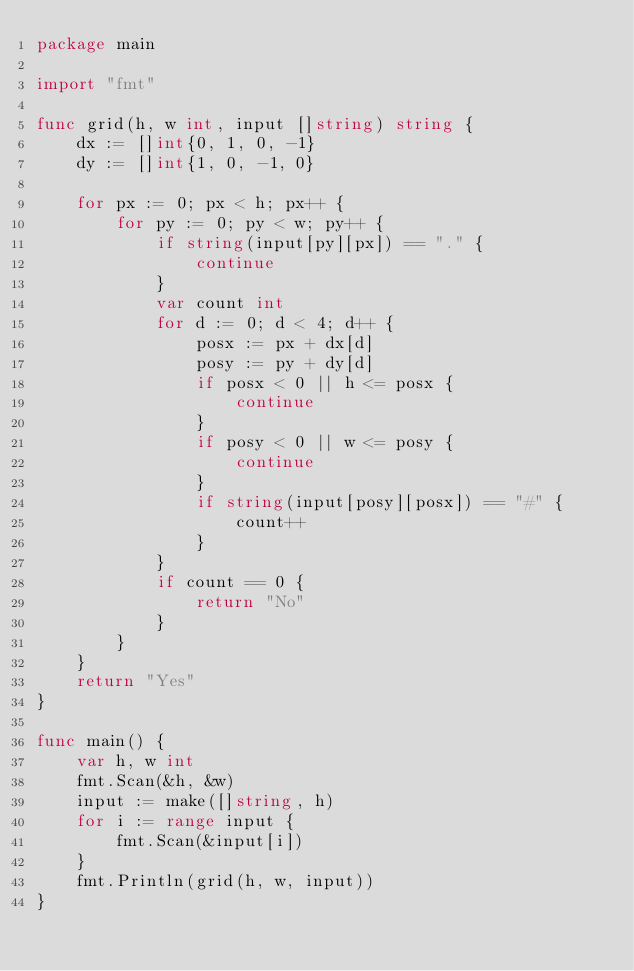<code> <loc_0><loc_0><loc_500><loc_500><_Go_>package main

import "fmt"

func grid(h, w int, input []string) string {
	dx := []int{0, 1, 0, -1}
	dy := []int{1, 0, -1, 0}

	for px := 0; px < h; px++ {
		for py := 0; py < w; py++ {
			if string(input[py][px]) == "." {
				continue
			}
			var count int
			for d := 0; d < 4; d++ {
				posx := px + dx[d]
				posy := py + dy[d]
				if posx < 0 || h <= posx {
					continue
				}
				if posy < 0 || w <= posy {
					continue
				}
				if string(input[posy][posx]) == "#" {
					count++
				}
			}
			if count == 0 {
				return "No"
			}
		}
	}
	return "Yes"
}

func main() {
	var h, w int
	fmt.Scan(&h, &w)
	input := make([]string, h)
	for i := range input {
		fmt.Scan(&input[i])
	}
	fmt.Println(grid(h, w, input))
}
</code> 